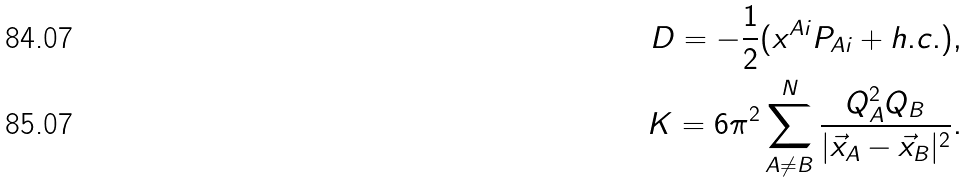Convert formula to latex. <formula><loc_0><loc_0><loc_500><loc_500>D = - \frac { 1 } { 2 } ( x ^ { A i } P _ { A i } + h . c . ) , \\ K = 6 \pi ^ { 2 } \sum _ { A \neq B } ^ { N } \frac { Q _ { A } ^ { 2 } Q _ { B } } { | \vec { x } _ { A } - \vec { x } _ { B } | ^ { 2 } } .</formula> 